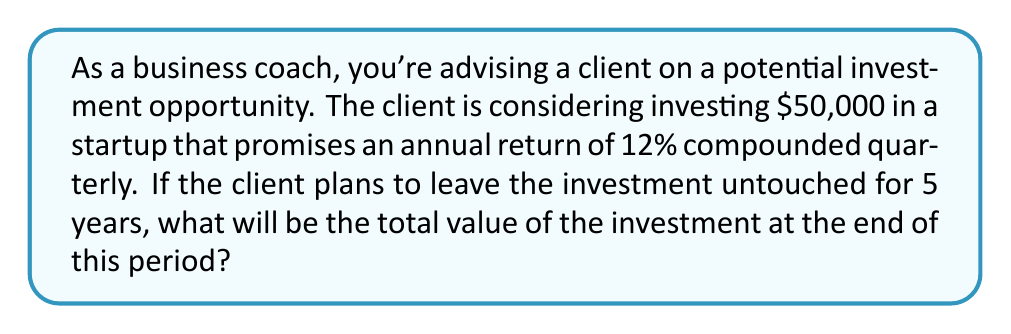Give your solution to this math problem. To solve this problem, we'll use the compound interest formula:

$$A = P(1 + \frac{r}{n})^{nt}$$

Where:
$A$ = Final amount
$P$ = Principal (initial investment)
$r$ = Annual interest rate (in decimal form)
$n$ = Number of times interest is compounded per year
$t$ = Number of years

Given:
$P = \$50,000$
$r = 12\% = 0.12$
$n = 4$ (compounded quarterly)
$t = 5$ years

Let's plug these values into the formula:

$$A = 50000(1 + \frac{0.12}{4})^{4 \times 5}$$

$$A = 50000(1 + 0.03)^{20}$$

$$A = 50000(1.03)^{20}$$

Now, let's calculate $(1.03)^{20}$:

$$(1.03)^{20} \approx 1.8061$$

Multiplying this by the principal:

$$A \approx 50000 \times 1.8061 = 90,305$$

Therefore, the total value of the investment after 5 years will be approximately $90,305.
Answer: $90,305 